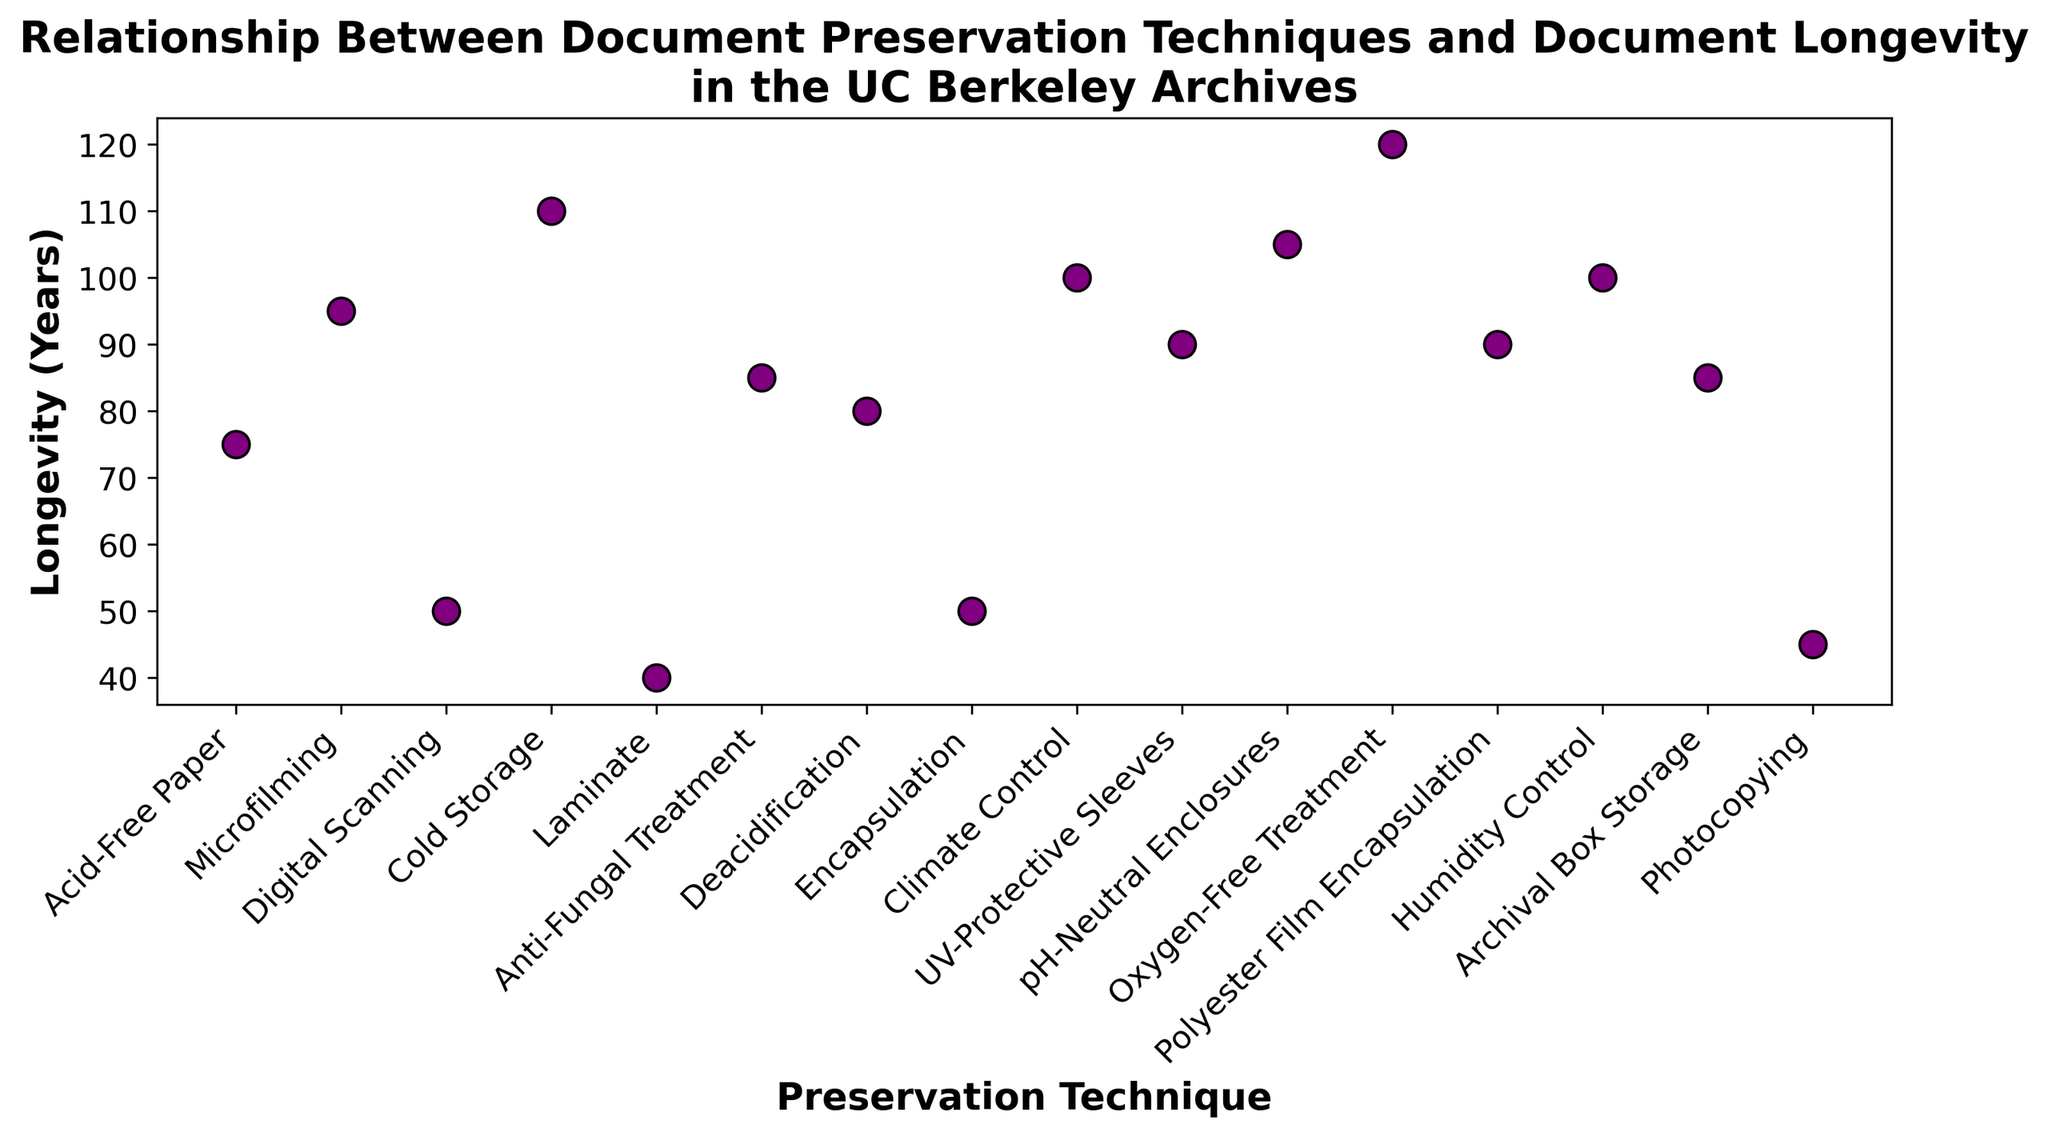Which preservation technique results in the longest document longevity? The scatter plot shows various preservation techniques on the x-axis and their corresponding document longevity on the y-axis. The technique with the highest y-value represents the longest longevity.
Answer: Oxygen-Free Treatment Which two techniques have the same document longevity? Looking across the y-axis values for matching points, "Humidity Control" and "Climate Control" both show the same longevity of 100 years. Similarly, "Encapsulation" and "Digital Scanning" both show a longevity of 50 years.
Answer: Humidity Control & Climate Control, Encapsulation & Digital Scanning What is the difference in longevity between Acid-Free Paper and UV-Protective Sleeves? The longevity of Acid-Free Paper is 75 years and UV-Protective Sleeves is 90 years. The difference is calculated by subtracting 75 from 90.
Answer: 15 years Which preservation technique is the least effective in terms of document longevity? The least effective technique will have the smallest y-value, which refers to the lowest longevity on the scatter plot.
Answer: Laminate What is the average document longevity of all the techniques depicted? Sum up all the longevities (75, 95, 50, 110, 40, 85, 80, 50, 100, 90, 105, 120, 90, 100, 85, 45) and divide by the number of techniques, which is 16. The sum is 1310, so the average is 1310 / 16.
Answer: 81.875 years How many techniques have a longevity of 90 years? Count the number of data points on the scatter plot that align with 90 on the y-axis.
Answer: 3 Is there any technique with a longevity between 50 and 60 years? Examine the scatter plot for any data points with y-values falling within the 50 to 60 range.
Answer: No What is the median longevity of the preservation techniques? Organize the longevities in ascending order (40, 45, 50, 50, 75, 80, 85, 85, 90, 90, 95, 100, 100, 105, 110, 120) and find the middle value(s). With 16 values, the median is the average of the 8th and 9th values, which are both 90.
Answer: 87.5 years How does the longevity of Deacidification compare to Microfilming? Locate both techniques on the scatter plot, where Deacidification has a longevity of 80 years and Microfilming has 95 years.
Answer: Microfilming is greater What is the combined longevity of the top three most effective preservation techniques? Identify the top three techniques with the highest longevities: Oxygen-Free Treatment (120), Cold Storage (110), and pH-Neutral Enclosures (105). Sum these values.
Answer: 335 years 